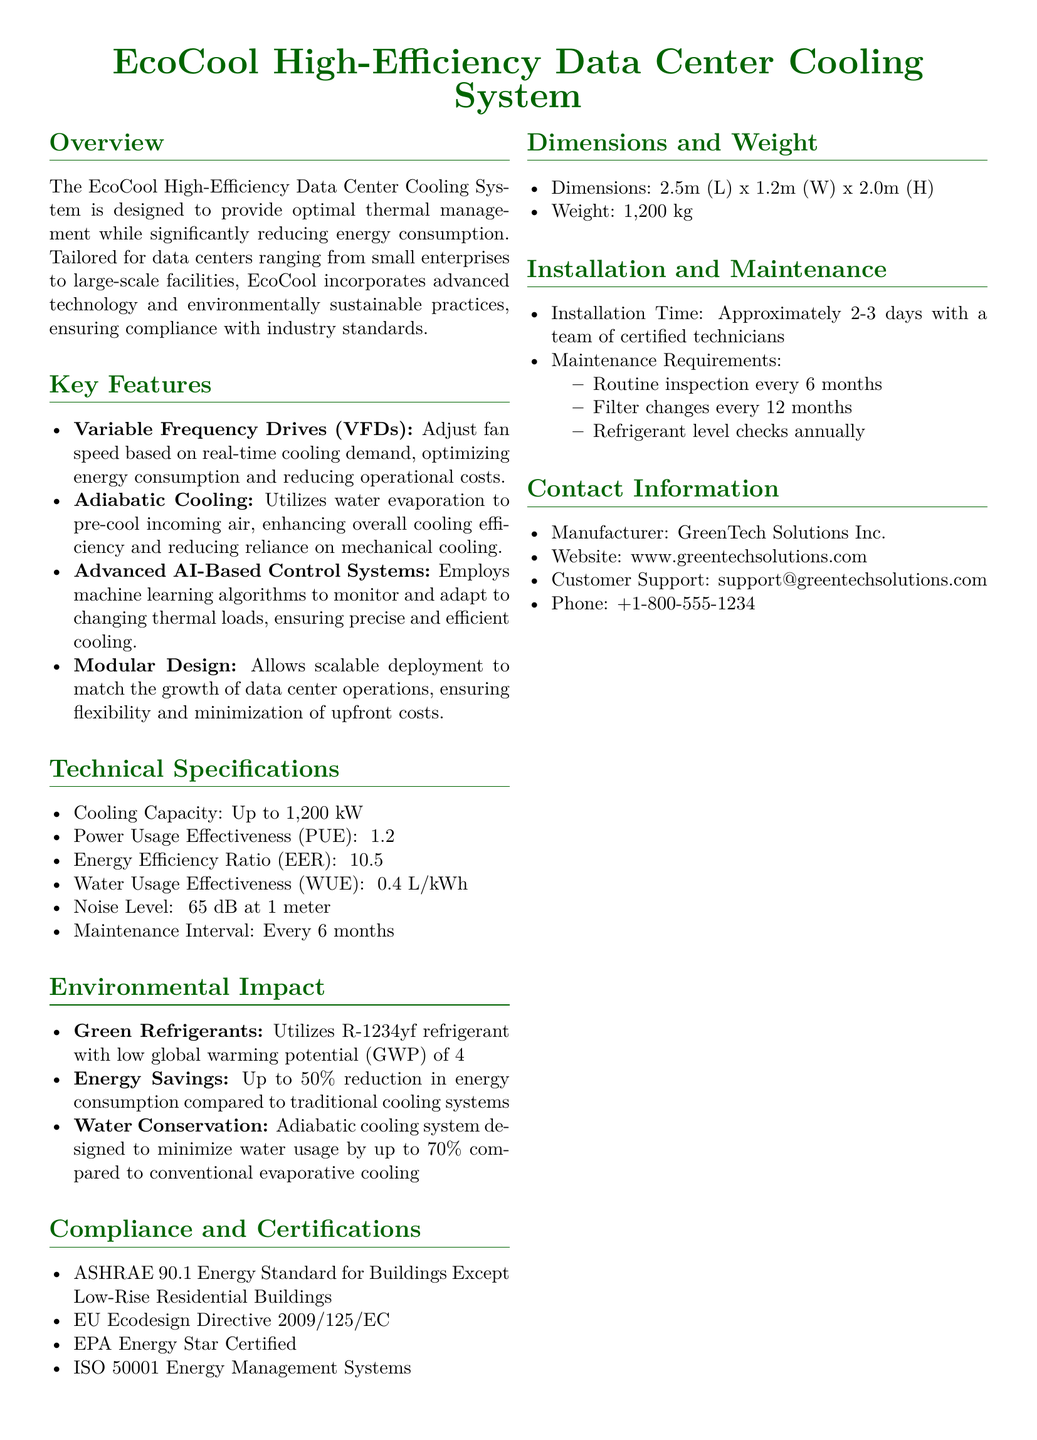What is the cooling capacity of the EcoCool system? The cooling capacity is specified in the document, which states it is up to 1,200 kW.
Answer: Up to 1,200 kW What is the Power Usage Effectiveness (PUE) of the cooling system? The document indicates that the PUE is less than or equal to 1.2.
Answer: ≤ 1.2 What technology does the EcoCool system use to reduce energy consumption? The system incorporates Variable Frequency Drives (VFDs) to adjust fan speed based on cooling demand.
Answer: Variable Frequency Drives (VFDs) How much energy savings can be achieved compared to traditional systems? The document mentions up to a 50% reduction in energy consumption.
Answer: Up to 50% What is the weight of the EcoCool cooling system? The weight of the cooling system is provided in the specifications as 1,200 kg.
Answer: 1,200 kg How often should maintenance be performed on the EcoCool system? The document specifies that maintenance should occur every 6 months.
Answer: Every 6 months Which refrigerant is used in the EcoCool system? The document states that it utilizes R-1234yf refrigerant.
Answer: R-1234yf What certification does the EcoCool system have related to energy management? The document lists ISO 50001 Energy Management Systems as a certification.
Answer: ISO 50001 How many days does installation take with certified technicians? The document states that installation takes approximately 2-3 days.
Answer: Approximately 2-3 days 